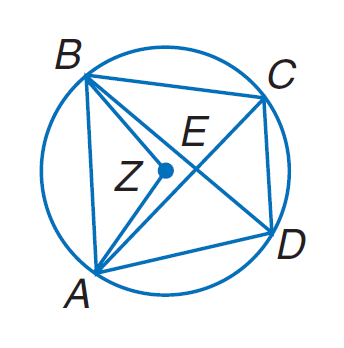Answer the mathemtical geometry problem and directly provide the correct option letter.
Question: Quadrilateral A B C D is inscribed in \odot Z such that m \angle B Z A = 104, m \widehat C B = 94, and A B \parallel D C. Find m \widehat B A.
Choices: A: 36 B: 90 C: 104 D: 120 C 